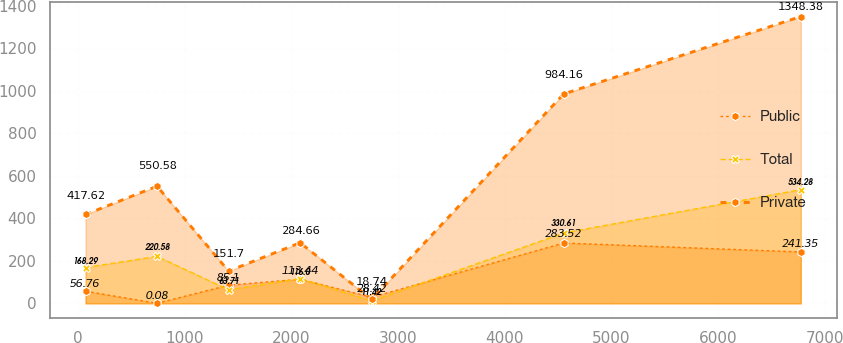<chart> <loc_0><loc_0><loc_500><loc_500><line_chart><ecel><fcel>Public<fcel>Total<fcel>Private<nl><fcel>68.21<fcel>56.76<fcel>168.29<fcel>417.62<nl><fcel>738.79<fcel>0.08<fcel>220.58<fcel>550.58<nl><fcel>1409.37<fcel>85.1<fcel>63.71<fcel>151.7<nl><fcel>2079.95<fcel>113.44<fcel>116<fcel>284.66<nl><fcel>2750.53<fcel>28.42<fcel>11.42<fcel>18.74<nl><fcel>4550.73<fcel>283.52<fcel>330.61<fcel>984.16<nl><fcel>6774.02<fcel>241.35<fcel>534.28<fcel>1348.38<nl></chart> 